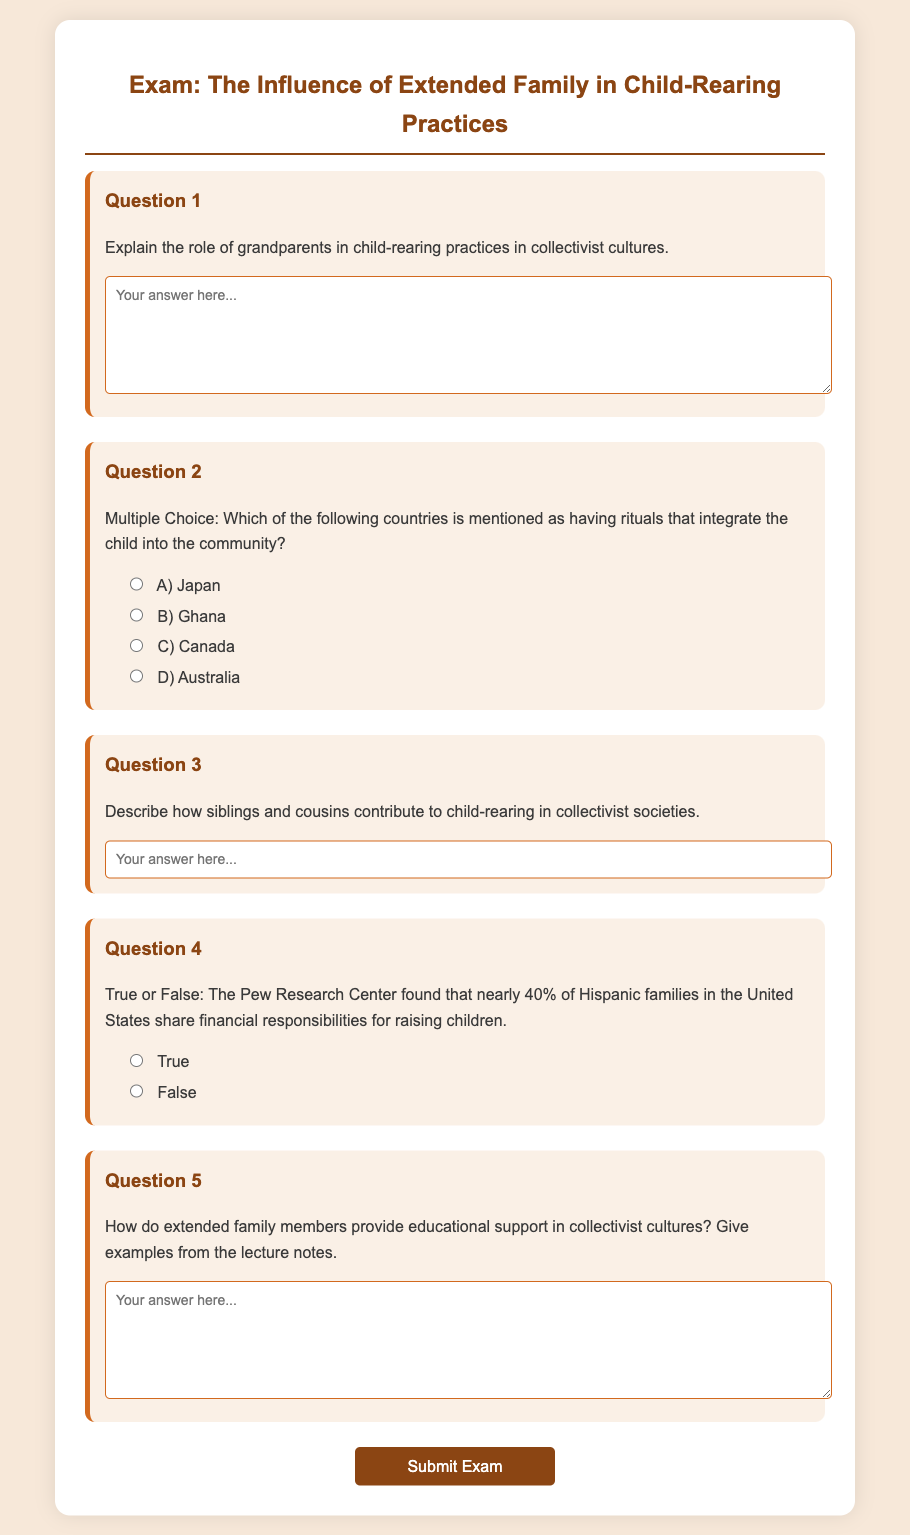What type of document is this? The document is an exam focused on the influence of extended family in child-rearing practices.
Answer: Exam How many questions are there in the exam? The document contains a total of five questions.
Answer: 5 What is the title of Question 3? The title of Question 3 is "Describe how siblings and cousins contribute to child-rearing in collectivist societies."
Answer: Describe how siblings and cousins contribute to child-rearing in collectivist societies Which option corresponds to the country mentioned for community rituals? The question lists Japan, Ghana, Canada, and Australia; any of these can be a correct answer.
Answer: Japan What percentage of Hispanic families share financial responsibilities for raising children? The document states that nearly 40% of Hispanic families in the United States share financial responsibilities.
Answer: 40% What is the main focus of the exam? The main focus of the exam is the influence of extended family in child-rearing practices.
Answer: The influence of extended family in child-rearing practices What type of support do extended family members provide in collectivist cultures? The question refers to educational support provided by extended family members.
Answer: Educational support What style of questions does the exam include? The exam includes true or false questions, multiple-choice questions, and short-answer questions.
Answer: True or false, multiple-choice, and short-answer questions 